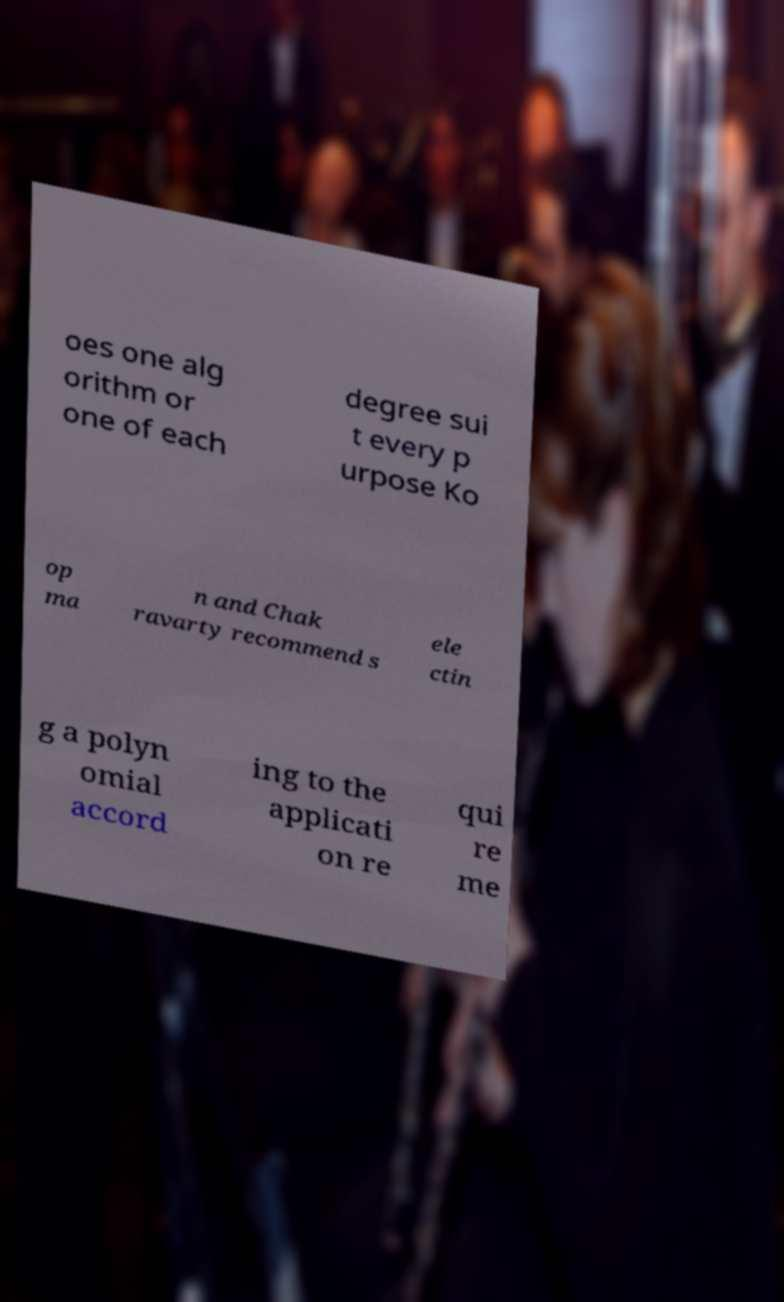Please read and relay the text visible in this image. What does it say? oes one alg orithm or one of each degree sui t every p urpose Ko op ma n and Chak ravarty recommend s ele ctin g a polyn omial accord ing to the applicati on re qui re me 